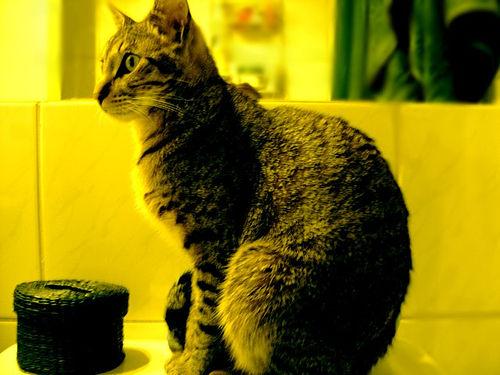What is the name of this cat?
Short answer required. Tiger. What color is the image?
Quick response, please. Yellow. What is directly in front of the cat?
Keep it brief. Basket. 